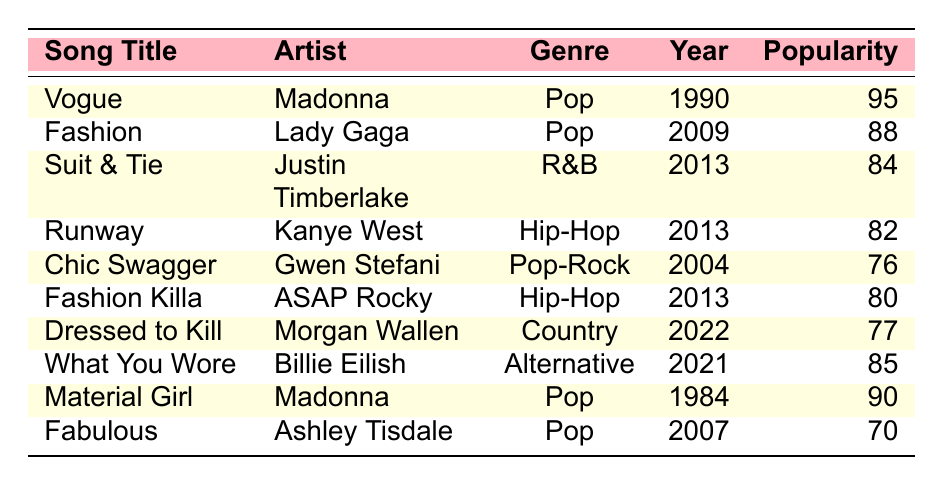What is the highest popularity rating among the fashion-inspired songs? The highest popularity rating is found in the song "Vogue" by Madonna, which has a rating of 95. This can be confirmed by looking through the ‘Popularity’ column for the maximum value.
Answer: 95 Which song by Lady Gaga is listed in the table? The table lists "Fashion" by Lady Gaga, as indicated in the ‘Song Title’ and ‘Artist’ columns.
Answer: Fashion How many fashion-inspired songs are from the Pop genre? There are five songs in the Pop genre: "Vogue," "Fashion," "Chic Swagger," "Material Girl," and "Fabulous." This is counted from the entries that show 'Pop' under the ‘Genre’ column.
Answer: 5 What is the average popularity rating of Hip-Hop songs in the table? The Hip-Hop songs listed are "Runway" (82) and "Fashion Killa" (80). To find the average, add these ratings: 82 + 80 = 162. Then divide by the number of Hip-Hop songs, which is 2, resulting in an average of 162/2 = 81.
Answer: 81 Is "Material Girl" more popular than "What You Wore"? "Material Girl" has a popularity rating of 90 while "What You Wore" has a rating of 85, thus making "Material Girl" more popular. This is assessed by directly comparing the ratings found in the ‘Popularity’ column.
Answer: Yes Which song had a better popularity rating, "Dressed to Kill" or "Suit & Tie"? "Suit & Tie" has a popularity rating of 84, while "Dressed to Kill" has a rating of 77. Since 84 is greater than 77, "Suit & Tie" is rated better. The comparison is made by examining the ratings in the ‘Popularity’ column for each song.
Answer: Suit & Tie What is the total popularity rating of all Pop songs listed? The Pop songs and their ratings are: "Vogue" (95), "Fashion" (88), "Chic Swagger" (76), "Material Girl" (90), and "Fabulous" (70). Adding these ratings gives: 95 + 88 + 76 + 90 + 70 = 419.
Answer: 419 Which artist has the least popular fashion-inspired song? The least popular song in the table is "Fabulous" by Ashley Tisdale with a popularity rating of 70. This is determined by reviewing the ‘Popularity’ ratings and identifying the minimum value.
Answer: Fabulous by Ashley Tisdale What percentage of songs released before 2000 belong to the Pop genre? There are 4 songs released before 2000: "Vogue" (1990), "Material Girl" (1984), "Fashion" (2009), and "Chic Swagger" (2004). Among these, 3 are in the Pop genre ("Vogue," "Fashion," and "Material Girl"). To calculate the percentage: (3 Pop songs / 4 total songs) * 100 = 75%.
Answer: 75% 